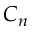Convert formula to latex. <formula><loc_0><loc_0><loc_500><loc_500>C _ { n }</formula> 